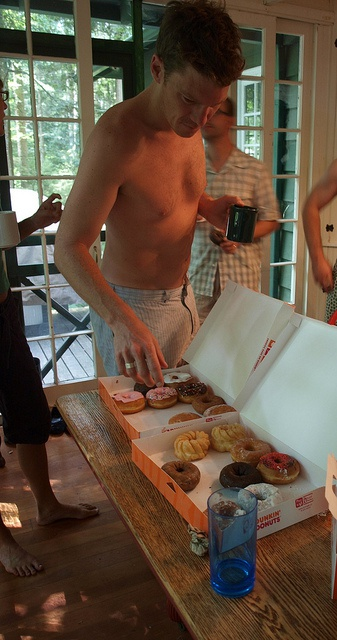Describe the objects in this image and their specific colors. I can see dining table in black, maroon, and darkgray tones, people in black, maroon, and gray tones, people in black, gray, and maroon tones, people in black, maroon, and gray tones, and cup in black, navy, gray, and blue tones in this image. 